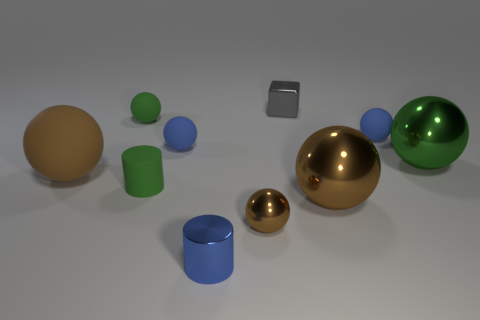Is there anything else that is the same shape as the small gray object?
Ensure brevity in your answer.  No. What material is the small brown sphere?
Provide a succinct answer. Metal. What color is the metallic sphere that is the same size as the block?
Offer a terse response. Brown. Are there any tiny things that are right of the small green matte thing that is behind the big green ball?
Make the answer very short. Yes. How many spheres are either brown rubber objects or rubber objects?
Your response must be concise. 4. There is a blue sphere on the right side of the small blue matte sphere in front of the blue sphere that is on the right side of the blue cylinder; what is its size?
Your response must be concise. Small. There is a small blue cylinder; are there any balls left of it?
Your answer should be compact. Yes. There is a big object that is the same color as the tiny rubber cylinder; what is its shape?
Provide a succinct answer. Sphere. What number of things are big things left of the small gray shiny cube or large brown rubber objects?
Your answer should be compact. 1. What is the size of the blue cylinder that is made of the same material as the tiny brown object?
Make the answer very short. Small. 